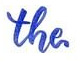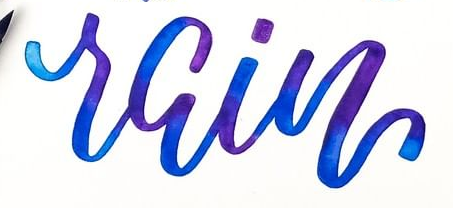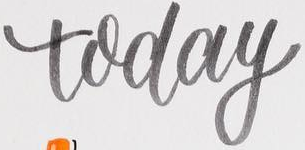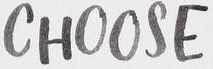Transcribe the words shown in these images in order, separated by a semicolon. the; rain; today; CHOOSE 